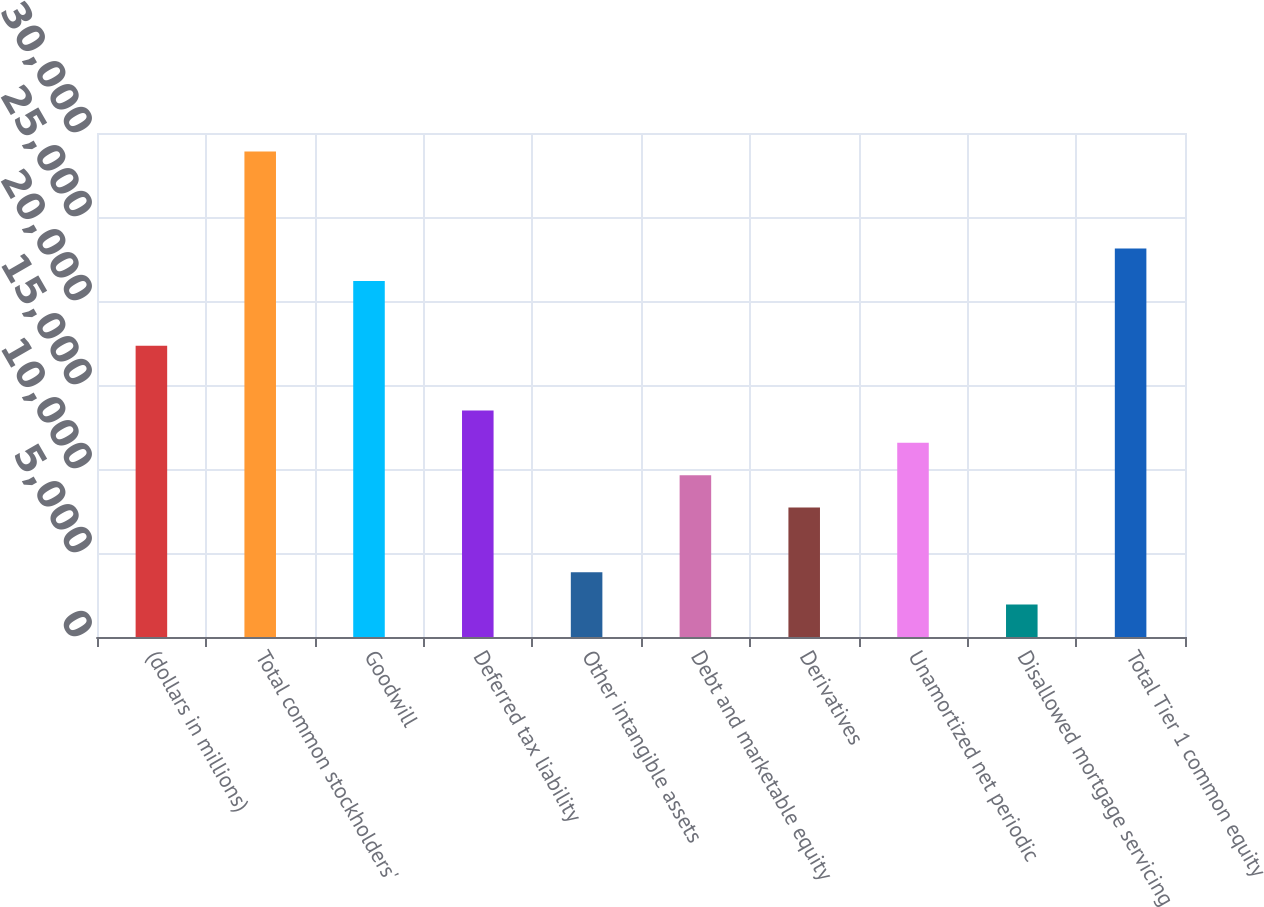Convert chart. <chart><loc_0><loc_0><loc_500><loc_500><bar_chart><fcel>(dollars in millions)<fcel>Total common stockholders'<fcel>Goodwill<fcel>Deferred tax liability<fcel>Other intangible assets<fcel>Debt and marketable equity<fcel>Derivatives<fcel>Unamortized net periodic<fcel>Disallowed mortgage servicing<fcel>Total Tier 1 common equity<nl><fcel>17341.4<fcel>28901<fcel>21194.6<fcel>13488.2<fcel>3855.2<fcel>9635<fcel>7708.4<fcel>11561.6<fcel>1928.6<fcel>23121.2<nl></chart> 